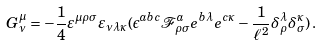<formula> <loc_0><loc_0><loc_500><loc_500>G ^ { \mu } _ { \nu } = - \frac { 1 } { 4 } \varepsilon ^ { \mu \rho \sigma } \varepsilon _ { \nu \lambda \kappa } ( \epsilon ^ { a b c } \mathcal { F } ^ { a } _ { \rho \sigma } e ^ { b \lambda } e ^ { c \kappa } - \frac { 1 } { \ell ^ { 2 } } \delta ^ { \lambda } _ { \rho } \delta ^ { \kappa } _ { \sigma } ) \, .</formula> 